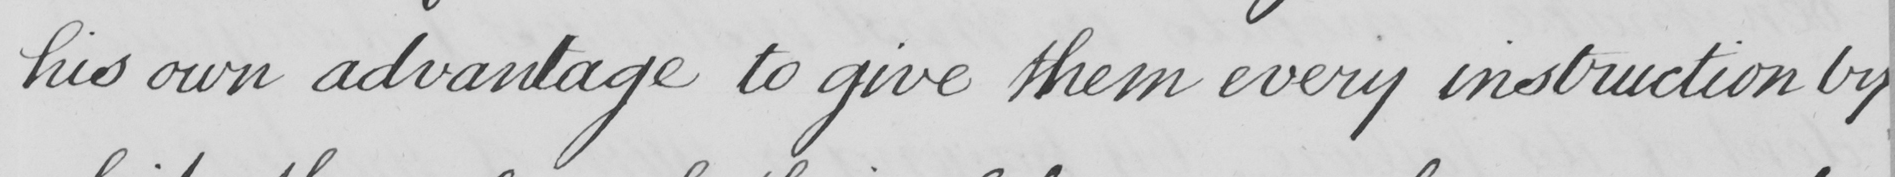What is written in this line of handwriting? his own advantage to give them every instruction by 